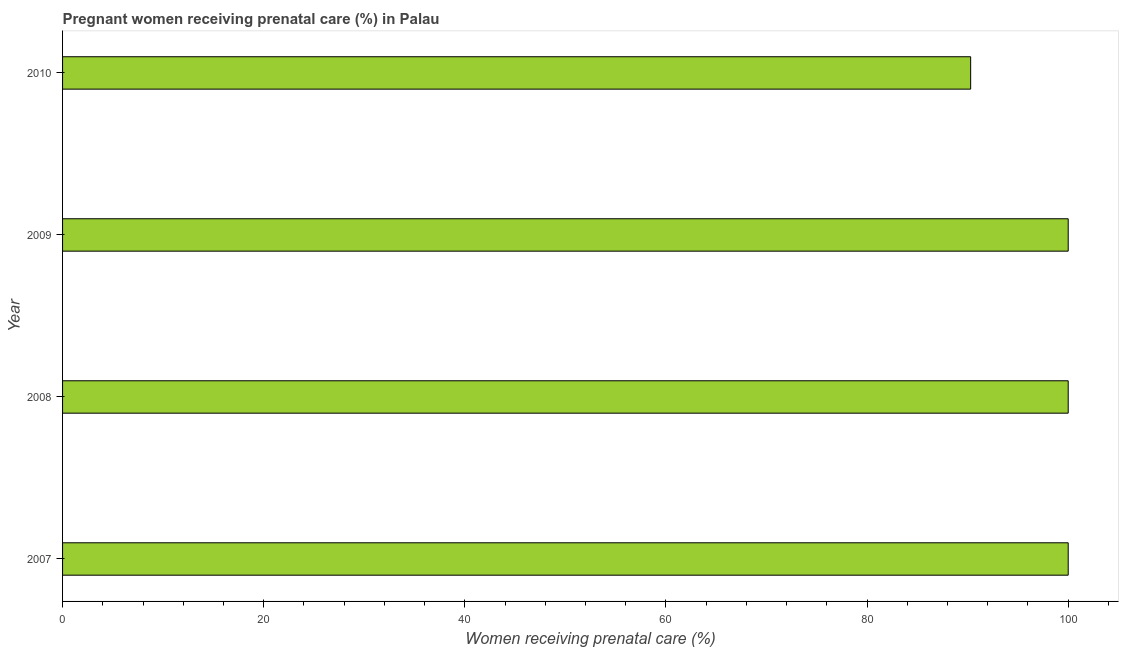Does the graph contain grids?
Make the answer very short. No. What is the title of the graph?
Provide a succinct answer. Pregnant women receiving prenatal care (%) in Palau. What is the label or title of the X-axis?
Make the answer very short. Women receiving prenatal care (%). What is the label or title of the Y-axis?
Provide a short and direct response. Year. Across all years, what is the maximum percentage of pregnant women receiving prenatal care?
Ensure brevity in your answer.  100. Across all years, what is the minimum percentage of pregnant women receiving prenatal care?
Offer a terse response. 90.3. In which year was the percentage of pregnant women receiving prenatal care minimum?
Your response must be concise. 2010. What is the sum of the percentage of pregnant women receiving prenatal care?
Make the answer very short. 390.3. What is the difference between the percentage of pregnant women receiving prenatal care in 2008 and 2010?
Your response must be concise. 9.7. What is the average percentage of pregnant women receiving prenatal care per year?
Your response must be concise. 97.58. What is the median percentage of pregnant women receiving prenatal care?
Give a very brief answer. 100. In how many years, is the percentage of pregnant women receiving prenatal care greater than 100 %?
Provide a succinct answer. 0. Do a majority of the years between 2009 and 2010 (inclusive) have percentage of pregnant women receiving prenatal care greater than 68 %?
Your answer should be compact. Yes. What is the ratio of the percentage of pregnant women receiving prenatal care in 2008 to that in 2010?
Provide a short and direct response. 1.11. Is the percentage of pregnant women receiving prenatal care in 2008 less than that in 2010?
Provide a succinct answer. No. Is the difference between the percentage of pregnant women receiving prenatal care in 2007 and 2010 greater than the difference between any two years?
Offer a terse response. Yes. Is the sum of the percentage of pregnant women receiving prenatal care in 2007 and 2010 greater than the maximum percentage of pregnant women receiving prenatal care across all years?
Provide a short and direct response. Yes. What is the difference between the highest and the lowest percentage of pregnant women receiving prenatal care?
Give a very brief answer. 9.7. In how many years, is the percentage of pregnant women receiving prenatal care greater than the average percentage of pregnant women receiving prenatal care taken over all years?
Provide a succinct answer. 3. How many bars are there?
Provide a short and direct response. 4. Are all the bars in the graph horizontal?
Give a very brief answer. Yes. How many years are there in the graph?
Provide a succinct answer. 4. What is the difference between two consecutive major ticks on the X-axis?
Provide a succinct answer. 20. Are the values on the major ticks of X-axis written in scientific E-notation?
Provide a succinct answer. No. What is the Women receiving prenatal care (%) in 2007?
Offer a very short reply. 100. What is the Women receiving prenatal care (%) of 2009?
Provide a short and direct response. 100. What is the Women receiving prenatal care (%) of 2010?
Give a very brief answer. 90.3. What is the difference between the Women receiving prenatal care (%) in 2007 and 2008?
Your answer should be compact. 0. What is the difference between the Women receiving prenatal care (%) in 2007 and 2009?
Ensure brevity in your answer.  0. What is the difference between the Women receiving prenatal care (%) in 2008 and 2009?
Provide a short and direct response. 0. What is the difference between the Women receiving prenatal care (%) in 2008 and 2010?
Your answer should be very brief. 9.7. What is the difference between the Women receiving prenatal care (%) in 2009 and 2010?
Your answer should be compact. 9.7. What is the ratio of the Women receiving prenatal care (%) in 2007 to that in 2010?
Make the answer very short. 1.11. What is the ratio of the Women receiving prenatal care (%) in 2008 to that in 2009?
Give a very brief answer. 1. What is the ratio of the Women receiving prenatal care (%) in 2008 to that in 2010?
Your response must be concise. 1.11. What is the ratio of the Women receiving prenatal care (%) in 2009 to that in 2010?
Offer a very short reply. 1.11. 